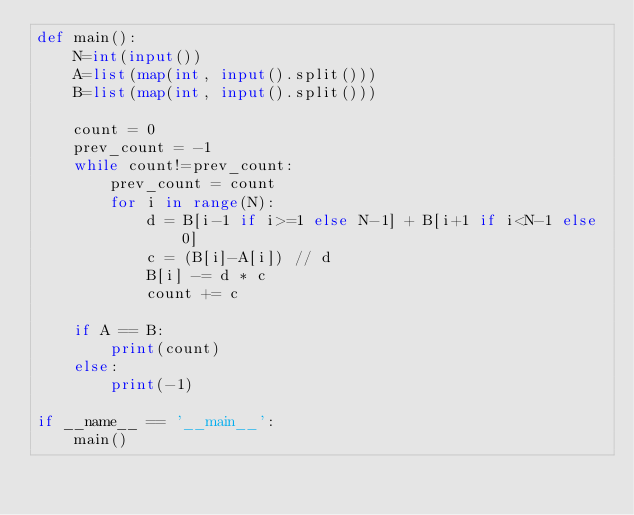<code> <loc_0><loc_0><loc_500><loc_500><_Python_>def main():
    N=int(input())
    A=list(map(int, input().split()))
    B=list(map(int, input().split()))

    count = 0
    prev_count = -1
    while count!=prev_count:
        prev_count = count
        for i in range(N):
            d = B[i-1 if i>=1 else N-1] + B[i+1 if i<N-1 else 0]
            c = (B[i]-A[i]) // d
            B[i] -= d * c
            count += c

    if A == B:
        print(count)
    else:
        print(-1)

if __name__ == '__main__':
    main()</code> 